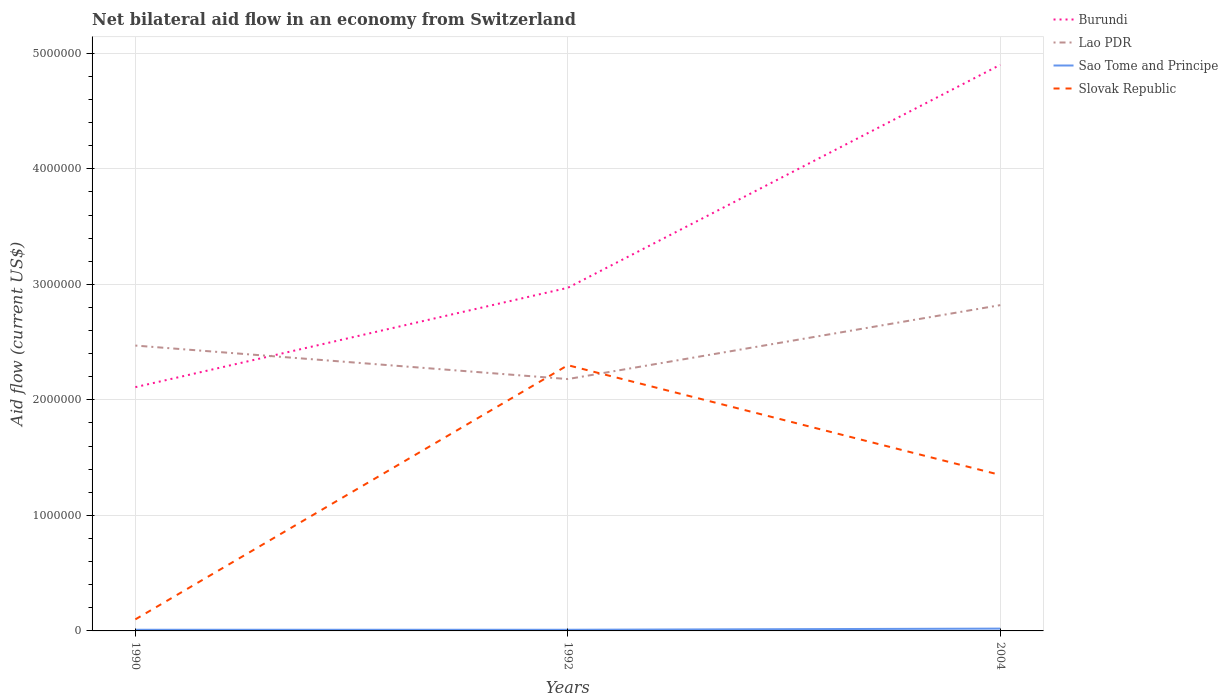Across all years, what is the maximum net bilateral aid flow in Burundi?
Your response must be concise. 2.11e+06. What is the total net bilateral aid flow in Slovak Republic in the graph?
Keep it short and to the point. -2.20e+06. What is the difference between the highest and the second highest net bilateral aid flow in Slovak Republic?
Offer a terse response. 2.20e+06. What is the difference between the highest and the lowest net bilateral aid flow in Slovak Republic?
Your answer should be compact. 2. Is the net bilateral aid flow in Sao Tome and Principe strictly greater than the net bilateral aid flow in Burundi over the years?
Your response must be concise. Yes. How many lines are there?
Make the answer very short. 4. Does the graph contain any zero values?
Provide a succinct answer. No. How many legend labels are there?
Provide a succinct answer. 4. How are the legend labels stacked?
Your answer should be very brief. Vertical. What is the title of the graph?
Provide a short and direct response. Net bilateral aid flow in an economy from Switzerland. What is the label or title of the Y-axis?
Offer a terse response. Aid flow (current US$). What is the Aid flow (current US$) in Burundi in 1990?
Provide a short and direct response. 2.11e+06. What is the Aid flow (current US$) in Lao PDR in 1990?
Make the answer very short. 2.47e+06. What is the Aid flow (current US$) of Slovak Republic in 1990?
Give a very brief answer. 1.00e+05. What is the Aid flow (current US$) of Burundi in 1992?
Provide a succinct answer. 2.97e+06. What is the Aid flow (current US$) of Lao PDR in 1992?
Ensure brevity in your answer.  2.18e+06. What is the Aid flow (current US$) in Sao Tome and Principe in 1992?
Offer a very short reply. 10000. What is the Aid flow (current US$) of Slovak Republic in 1992?
Your answer should be compact. 2.30e+06. What is the Aid flow (current US$) of Burundi in 2004?
Make the answer very short. 4.90e+06. What is the Aid flow (current US$) in Lao PDR in 2004?
Your response must be concise. 2.82e+06. What is the Aid flow (current US$) of Slovak Republic in 2004?
Your response must be concise. 1.35e+06. Across all years, what is the maximum Aid flow (current US$) of Burundi?
Give a very brief answer. 4.90e+06. Across all years, what is the maximum Aid flow (current US$) of Lao PDR?
Provide a short and direct response. 2.82e+06. Across all years, what is the maximum Aid flow (current US$) in Sao Tome and Principe?
Your answer should be very brief. 2.00e+04. Across all years, what is the maximum Aid flow (current US$) in Slovak Republic?
Keep it short and to the point. 2.30e+06. Across all years, what is the minimum Aid flow (current US$) in Burundi?
Ensure brevity in your answer.  2.11e+06. Across all years, what is the minimum Aid flow (current US$) of Lao PDR?
Your response must be concise. 2.18e+06. Across all years, what is the minimum Aid flow (current US$) in Sao Tome and Principe?
Offer a terse response. 10000. Across all years, what is the minimum Aid flow (current US$) of Slovak Republic?
Keep it short and to the point. 1.00e+05. What is the total Aid flow (current US$) in Burundi in the graph?
Your answer should be compact. 9.98e+06. What is the total Aid flow (current US$) in Lao PDR in the graph?
Your response must be concise. 7.47e+06. What is the total Aid flow (current US$) in Slovak Republic in the graph?
Your response must be concise. 3.75e+06. What is the difference between the Aid flow (current US$) in Burundi in 1990 and that in 1992?
Give a very brief answer. -8.60e+05. What is the difference between the Aid flow (current US$) of Sao Tome and Principe in 1990 and that in 1992?
Provide a short and direct response. 0. What is the difference between the Aid flow (current US$) in Slovak Republic in 1990 and that in 1992?
Ensure brevity in your answer.  -2.20e+06. What is the difference between the Aid flow (current US$) in Burundi in 1990 and that in 2004?
Give a very brief answer. -2.79e+06. What is the difference between the Aid flow (current US$) in Lao PDR in 1990 and that in 2004?
Your answer should be very brief. -3.50e+05. What is the difference between the Aid flow (current US$) of Sao Tome and Principe in 1990 and that in 2004?
Ensure brevity in your answer.  -10000. What is the difference between the Aid flow (current US$) in Slovak Republic in 1990 and that in 2004?
Provide a succinct answer. -1.25e+06. What is the difference between the Aid flow (current US$) of Burundi in 1992 and that in 2004?
Your answer should be very brief. -1.93e+06. What is the difference between the Aid flow (current US$) of Lao PDR in 1992 and that in 2004?
Give a very brief answer. -6.40e+05. What is the difference between the Aid flow (current US$) of Slovak Republic in 1992 and that in 2004?
Make the answer very short. 9.50e+05. What is the difference between the Aid flow (current US$) of Burundi in 1990 and the Aid flow (current US$) of Lao PDR in 1992?
Offer a very short reply. -7.00e+04. What is the difference between the Aid flow (current US$) of Burundi in 1990 and the Aid flow (current US$) of Sao Tome and Principe in 1992?
Give a very brief answer. 2.10e+06. What is the difference between the Aid flow (current US$) of Burundi in 1990 and the Aid flow (current US$) of Slovak Republic in 1992?
Your answer should be very brief. -1.90e+05. What is the difference between the Aid flow (current US$) of Lao PDR in 1990 and the Aid flow (current US$) of Sao Tome and Principe in 1992?
Provide a short and direct response. 2.46e+06. What is the difference between the Aid flow (current US$) of Sao Tome and Principe in 1990 and the Aid flow (current US$) of Slovak Republic in 1992?
Your answer should be compact. -2.29e+06. What is the difference between the Aid flow (current US$) in Burundi in 1990 and the Aid flow (current US$) in Lao PDR in 2004?
Your answer should be very brief. -7.10e+05. What is the difference between the Aid flow (current US$) of Burundi in 1990 and the Aid flow (current US$) of Sao Tome and Principe in 2004?
Offer a terse response. 2.09e+06. What is the difference between the Aid flow (current US$) of Burundi in 1990 and the Aid flow (current US$) of Slovak Republic in 2004?
Your answer should be very brief. 7.60e+05. What is the difference between the Aid flow (current US$) of Lao PDR in 1990 and the Aid flow (current US$) of Sao Tome and Principe in 2004?
Keep it short and to the point. 2.45e+06. What is the difference between the Aid flow (current US$) of Lao PDR in 1990 and the Aid flow (current US$) of Slovak Republic in 2004?
Your response must be concise. 1.12e+06. What is the difference between the Aid flow (current US$) in Sao Tome and Principe in 1990 and the Aid flow (current US$) in Slovak Republic in 2004?
Your response must be concise. -1.34e+06. What is the difference between the Aid flow (current US$) in Burundi in 1992 and the Aid flow (current US$) in Sao Tome and Principe in 2004?
Provide a short and direct response. 2.95e+06. What is the difference between the Aid flow (current US$) of Burundi in 1992 and the Aid flow (current US$) of Slovak Republic in 2004?
Your answer should be compact. 1.62e+06. What is the difference between the Aid flow (current US$) in Lao PDR in 1992 and the Aid flow (current US$) in Sao Tome and Principe in 2004?
Ensure brevity in your answer.  2.16e+06. What is the difference between the Aid flow (current US$) in Lao PDR in 1992 and the Aid flow (current US$) in Slovak Republic in 2004?
Your answer should be very brief. 8.30e+05. What is the difference between the Aid flow (current US$) of Sao Tome and Principe in 1992 and the Aid flow (current US$) of Slovak Republic in 2004?
Provide a succinct answer. -1.34e+06. What is the average Aid flow (current US$) in Burundi per year?
Offer a terse response. 3.33e+06. What is the average Aid flow (current US$) of Lao PDR per year?
Make the answer very short. 2.49e+06. What is the average Aid flow (current US$) in Sao Tome and Principe per year?
Offer a very short reply. 1.33e+04. What is the average Aid flow (current US$) of Slovak Republic per year?
Your answer should be very brief. 1.25e+06. In the year 1990, what is the difference between the Aid flow (current US$) of Burundi and Aid flow (current US$) of Lao PDR?
Provide a short and direct response. -3.60e+05. In the year 1990, what is the difference between the Aid flow (current US$) in Burundi and Aid flow (current US$) in Sao Tome and Principe?
Give a very brief answer. 2.10e+06. In the year 1990, what is the difference between the Aid flow (current US$) in Burundi and Aid flow (current US$) in Slovak Republic?
Your response must be concise. 2.01e+06. In the year 1990, what is the difference between the Aid flow (current US$) in Lao PDR and Aid flow (current US$) in Sao Tome and Principe?
Your answer should be compact. 2.46e+06. In the year 1990, what is the difference between the Aid flow (current US$) of Lao PDR and Aid flow (current US$) of Slovak Republic?
Give a very brief answer. 2.37e+06. In the year 1990, what is the difference between the Aid flow (current US$) in Sao Tome and Principe and Aid flow (current US$) in Slovak Republic?
Provide a short and direct response. -9.00e+04. In the year 1992, what is the difference between the Aid flow (current US$) of Burundi and Aid flow (current US$) of Lao PDR?
Your answer should be compact. 7.90e+05. In the year 1992, what is the difference between the Aid flow (current US$) in Burundi and Aid flow (current US$) in Sao Tome and Principe?
Make the answer very short. 2.96e+06. In the year 1992, what is the difference between the Aid flow (current US$) of Burundi and Aid flow (current US$) of Slovak Republic?
Your answer should be compact. 6.70e+05. In the year 1992, what is the difference between the Aid flow (current US$) in Lao PDR and Aid flow (current US$) in Sao Tome and Principe?
Provide a succinct answer. 2.17e+06. In the year 1992, what is the difference between the Aid flow (current US$) in Sao Tome and Principe and Aid flow (current US$) in Slovak Republic?
Keep it short and to the point. -2.29e+06. In the year 2004, what is the difference between the Aid flow (current US$) in Burundi and Aid flow (current US$) in Lao PDR?
Ensure brevity in your answer.  2.08e+06. In the year 2004, what is the difference between the Aid flow (current US$) in Burundi and Aid flow (current US$) in Sao Tome and Principe?
Your answer should be compact. 4.88e+06. In the year 2004, what is the difference between the Aid flow (current US$) in Burundi and Aid flow (current US$) in Slovak Republic?
Give a very brief answer. 3.55e+06. In the year 2004, what is the difference between the Aid flow (current US$) in Lao PDR and Aid flow (current US$) in Sao Tome and Principe?
Make the answer very short. 2.80e+06. In the year 2004, what is the difference between the Aid flow (current US$) in Lao PDR and Aid flow (current US$) in Slovak Republic?
Offer a very short reply. 1.47e+06. In the year 2004, what is the difference between the Aid flow (current US$) of Sao Tome and Principe and Aid flow (current US$) of Slovak Republic?
Ensure brevity in your answer.  -1.33e+06. What is the ratio of the Aid flow (current US$) in Burundi in 1990 to that in 1992?
Provide a succinct answer. 0.71. What is the ratio of the Aid flow (current US$) in Lao PDR in 1990 to that in 1992?
Provide a succinct answer. 1.13. What is the ratio of the Aid flow (current US$) in Slovak Republic in 1990 to that in 1992?
Your answer should be very brief. 0.04. What is the ratio of the Aid flow (current US$) of Burundi in 1990 to that in 2004?
Make the answer very short. 0.43. What is the ratio of the Aid flow (current US$) in Lao PDR in 1990 to that in 2004?
Give a very brief answer. 0.88. What is the ratio of the Aid flow (current US$) of Slovak Republic in 1990 to that in 2004?
Provide a succinct answer. 0.07. What is the ratio of the Aid flow (current US$) of Burundi in 1992 to that in 2004?
Provide a succinct answer. 0.61. What is the ratio of the Aid flow (current US$) in Lao PDR in 1992 to that in 2004?
Your answer should be very brief. 0.77. What is the ratio of the Aid flow (current US$) in Slovak Republic in 1992 to that in 2004?
Your response must be concise. 1.7. What is the difference between the highest and the second highest Aid flow (current US$) of Burundi?
Your answer should be very brief. 1.93e+06. What is the difference between the highest and the second highest Aid flow (current US$) in Lao PDR?
Offer a terse response. 3.50e+05. What is the difference between the highest and the second highest Aid flow (current US$) in Slovak Republic?
Keep it short and to the point. 9.50e+05. What is the difference between the highest and the lowest Aid flow (current US$) in Burundi?
Make the answer very short. 2.79e+06. What is the difference between the highest and the lowest Aid flow (current US$) of Lao PDR?
Your answer should be compact. 6.40e+05. What is the difference between the highest and the lowest Aid flow (current US$) of Slovak Republic?
Give a very brief answer. 2.20e+06. 